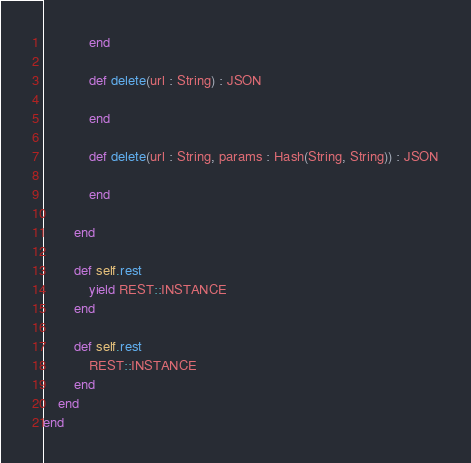<code> <loc_0><loc_0><loc_500><loc_500><_Crystal_>
            end

            def delete(url : String) : JSON

            end

            def delete(url : String, params : Hash(String, String)) : JSON

            end

        end

        def self.rest
            yield REST::INSTANCE
        end

        def self.rest
            REST::INSTANCE
        end
    end
end</code> 